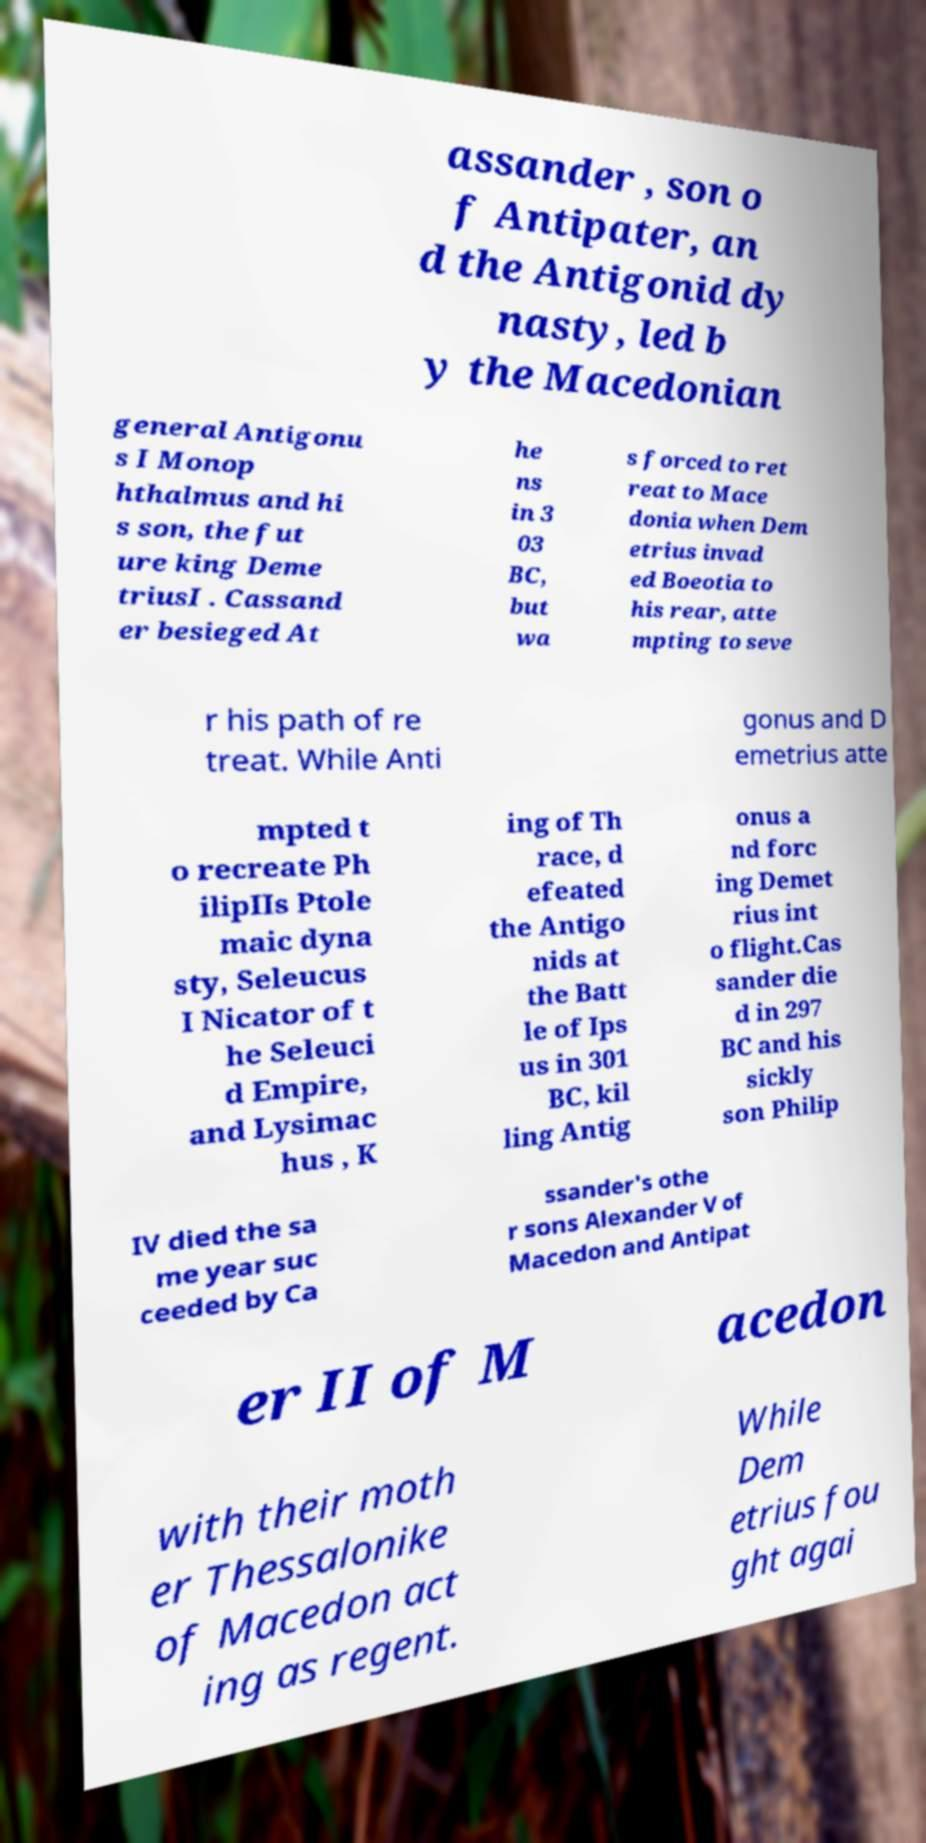There's text embedded in this image that I need extracted. Can you transcribe it verbatim? assander , son o f Antipater, an d the Antigonid dy nasty, led b y the Macedonian general Antigonu s I Monop hthalmus and hi s son, the fut ure king Deme triusI . Cassand er besieged At he ns in 3 03 BC, but wa s forced to ret reat to Mace donia when Dem etrius invad ed Boeotia to his rear, atte mpting to seve r his path of re treat. While Anti gonus and D emetrius atte mpted t o recreate Ph ilipIIs Ptole maic dyna sty, Seleucus I Nicator of t he Seleuci d Empire, and Lysimac hus , K ing of Th race, d efeated the Antigo nids at the Batt le of Ips us in 301 BC, kil ling Antig onus a nd forc ing Demet rius int o flight.Cas sander die d in 297 BC and his sickly son Philip IV died the sa me year suc ceeded by Ca ssander's othe r sons Alexander V of Macedon and Antipat er II of M acedon with their moth er Thessalonike of Macedon act ing as regent. While Dem etrius fou ght agai 